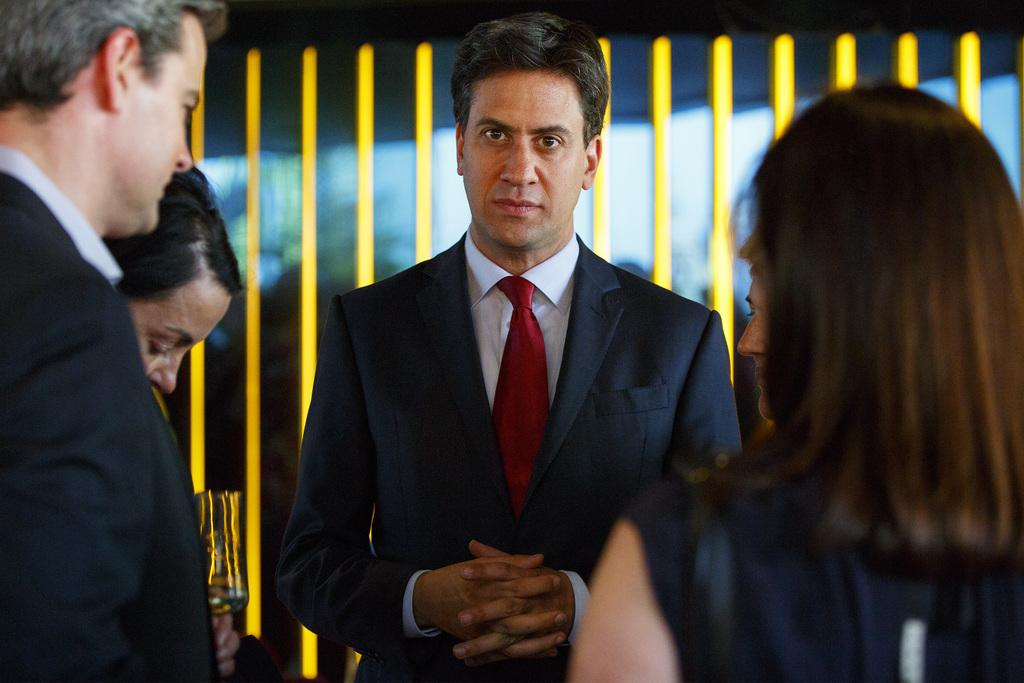How many people are present in the image? There are a few people in the image. Can you describe any specific features of the background in the image? Yes, there are yellow colored poles in the background of the image. How many friends are visiting the control room in the image? There is no mention of friends or a control room in the image; it only shows a few people and yellow colored poles in the background. 